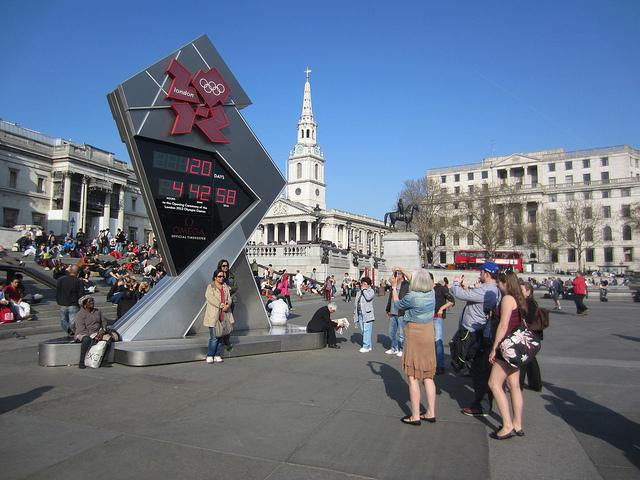What event do the rings signify? olympics 